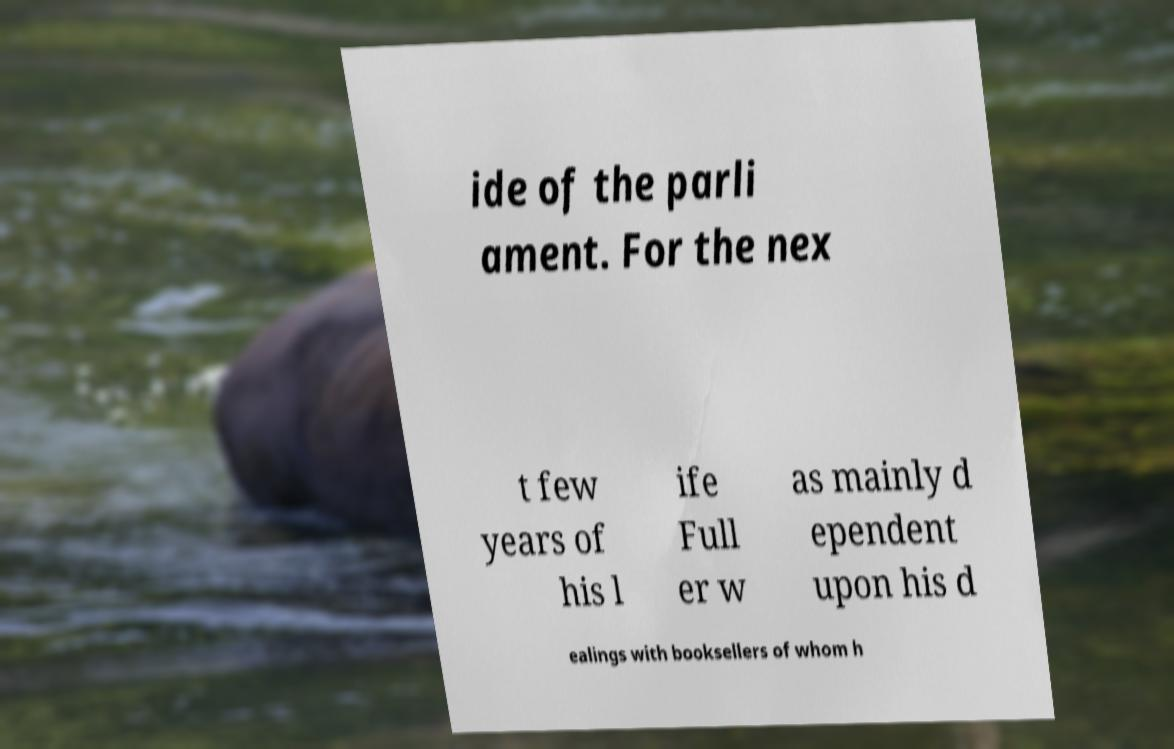Could you assist in decoding the text presented in this image and type it out clearly? ide of the parli ament. For the nex t few years of his l ife Full er w as mainly d ependent upon his d ealings with booksellers of whom h 